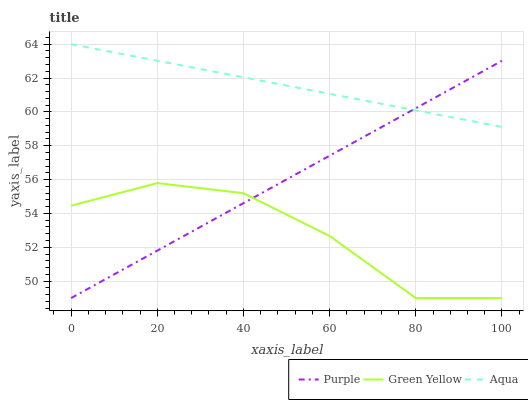Does Green Yellow have the minimum area under the curve?
Answer yes or no. Yes. Does Aqua have the maximum area under the curve?
Answer yes or no. Yes. Does Aqua have the minimum area under the curve?
Answer yes or no. No. Does Green Yellow have the maximum area under the curve?
Answer yes or no. No. Is Purple the smoothest?
Answer yes or no. Yes. Is Green Yellow the roughest?
Answer yes or no. Yes. Is Aqua the smoothest?
Answer yes or no. No. Is Aqua the roughest?
Answer yes or no. No. Does Aqua have the lowest value?
Answer yes or no. No. Does Aqua have the highest value?
Answer yes or no. Yes. Does Green Yellow have the highest value?
Answer yes or no. No. Is Green Yellow less than Aqua?
Answer yes or no. Yes. Is Aqua greater than Green Yellow?
Answer yes or no. Yes. Does Green Yellow intersect Aqua?
Answer yes or no. No. 